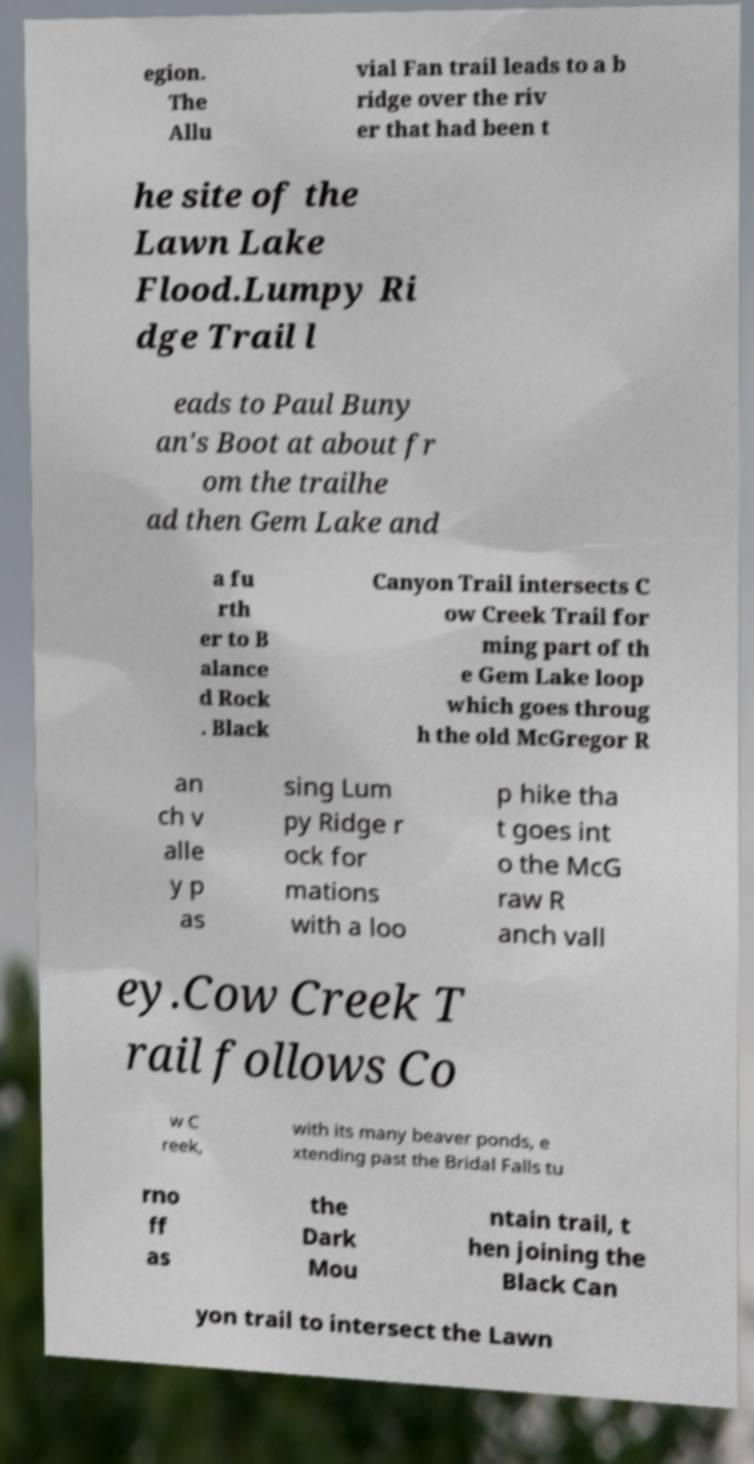Could you extract and type out the text from this image? egion. The Allu vial Fan trail leads to a b ridge over the riv er that had been t he site of the Lawn Lake Flood.Lumpy Ri dge Trail l eads to Paul Buny an's Boot at about fr om the trailhe ad then Gem Lake and a fu rth er to B alance d Rock . Black Canyon Trail intersects C ow Creek Trail for ming part of th e Gem Lake loop which goes throug h the old McGregor R an ch v alle y p as sing Lum py Ridge r ock for mations with a loo p hike tha t goes int o the McG raw R anch vall ey.Cow Creek T rail follows Co w C reek, with its many beaver ponds, e xtending past the Bridal Falls tu rno ff as the Dark Mou ntain trail, t hen joining the Black Can yon trail to intersect the Lawn 